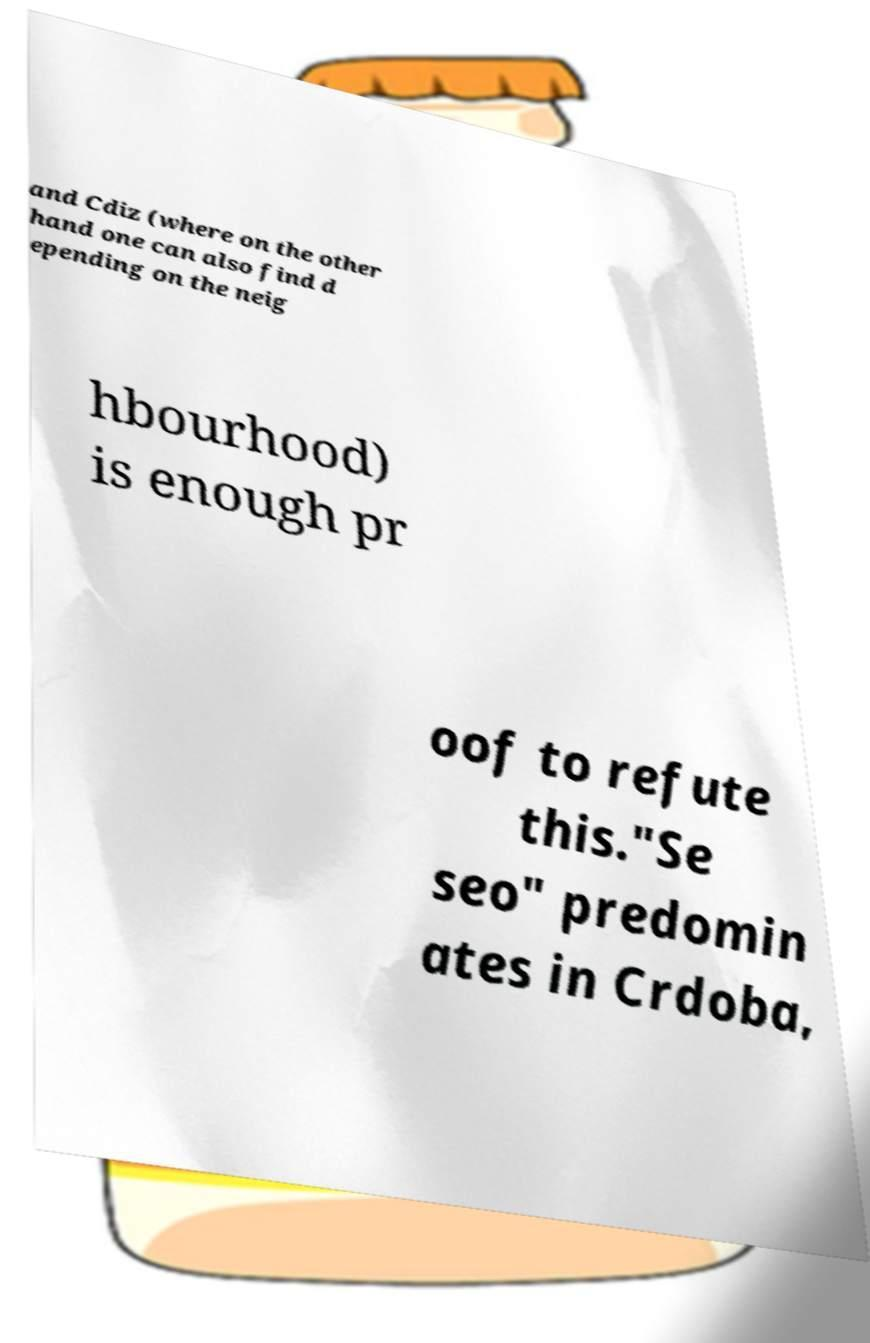For documentation purposes, I need the text within this image transcribed. Could you provide that? and Cdiz (where on the other hand one can also find d epending on the neig hbourhood) is enough pr oof to refute this."Se seo" predomin ates in Crdoba, 